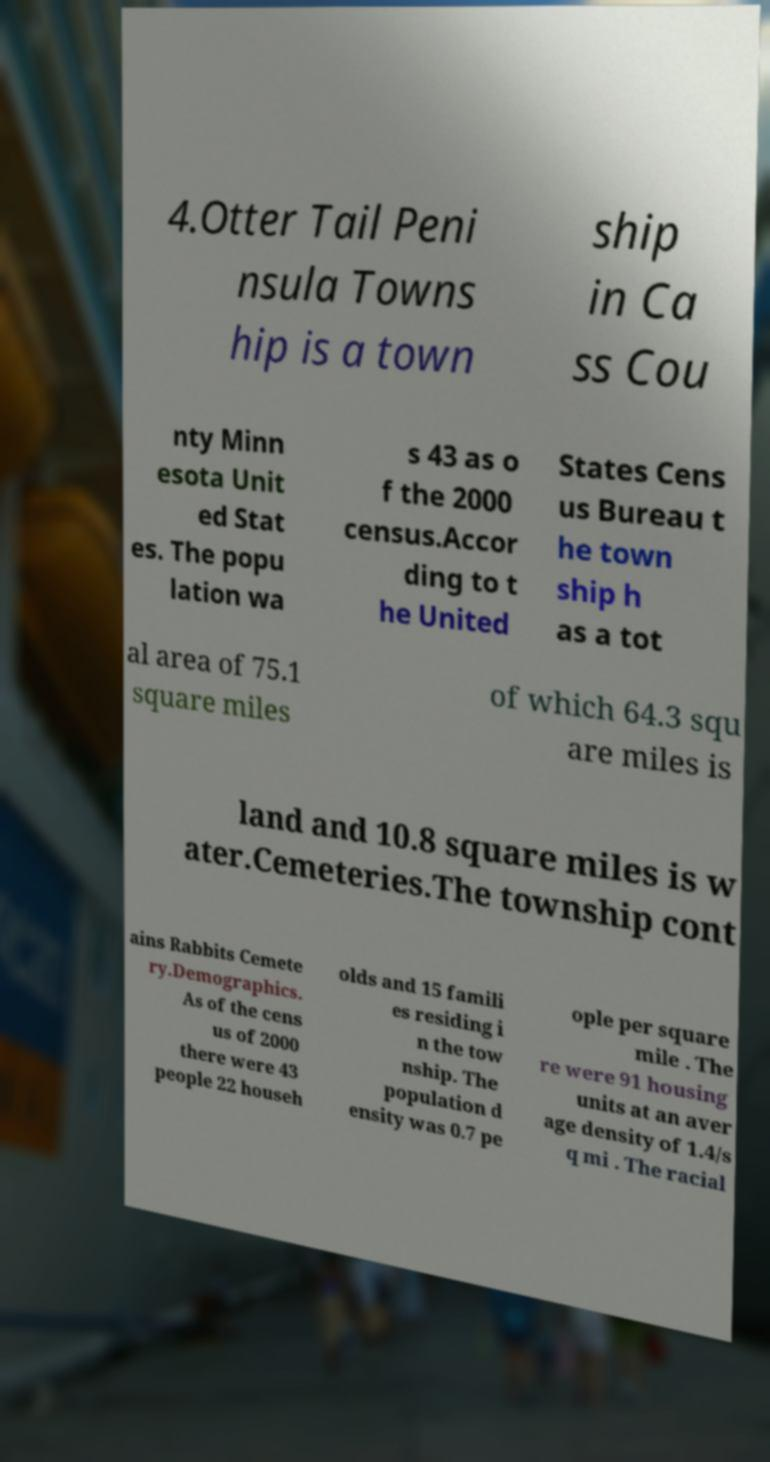For documentation purposes, I need the text within this image transcribed. Could you provide that? 4.Otter Tail Peni nsula Towns hip is a town ship in Ca ss Cou nty Minn esota Unit ed Stat es. The popu lation wa s 43 as o f the 2000 census.Accor ding to t he United States Cens us Bureau t he town ship h as a tot al area of 75.1 square miles of which 64.3 squ are miles is land and 10.8 square miles is w ater.Cemeteries.The township cont ains Rabbits Cemete ry.Demographics. As of the cens us of 2000 there were 43 people 22 househ olds and 15 famili es residing i n the tow nship. The population d ensity was 0.7 pe ople per square mile . The re were 91 housing units at an aver age density of 1.4/s q mi . The racial 